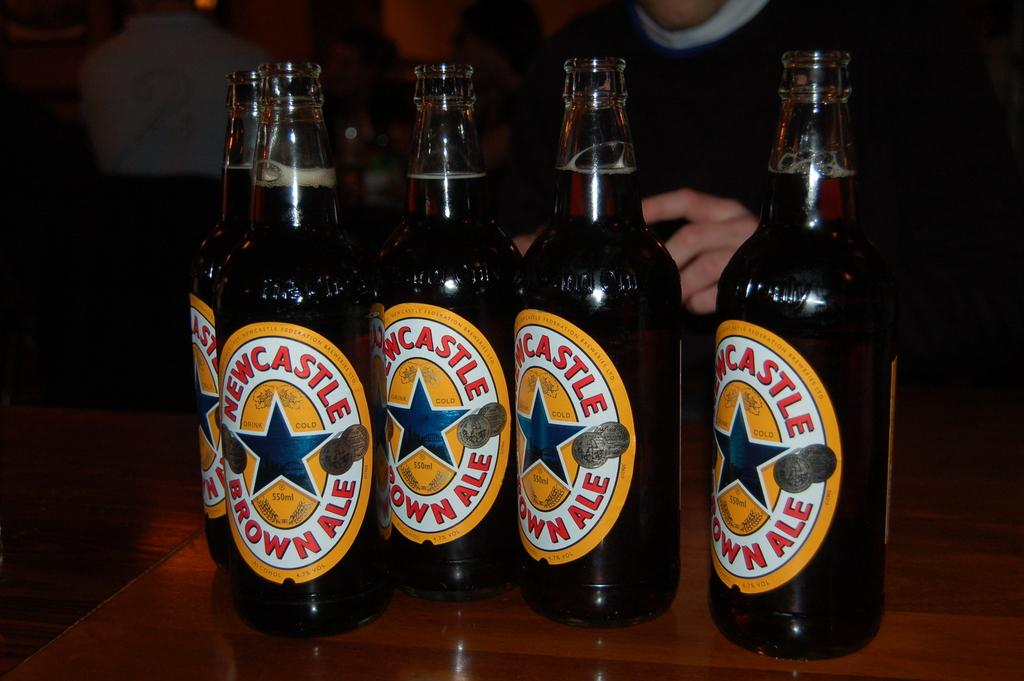Provide a one-sentence caption for the provided image. beer bottles that have the place of Newcastle on them. 